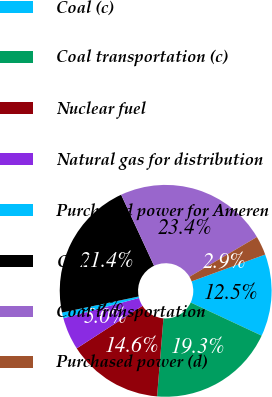Convert chart to OTSL. <chart><loc_0><loc_0><loc_500><loc_500><pie_chart><fcel>Coal (c)<fcel>Coal transportation (c)<fcel>Nuclear fuel<fcel>Natural gas for distribution<fcel>Purchased power for Ameren<fcel>Coal<fcel>Coal transportation<fcel>Purchased power (d)<nl><fcel>12.52%<fcel>19.34%<fcel>14.57%<fcel>4.97%<fcel>0.88%<fcel>21.38%<fcel>23.42%<fcel>2.92%<nl></chart> 